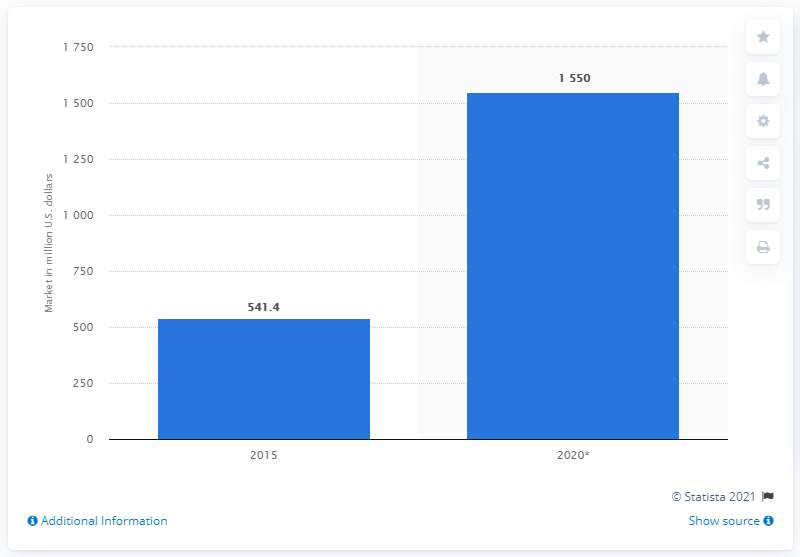Identify some key points in this picture. The e-mail encryption market began to grow in 2015. The estimated value of the global e-mail encryption market in 2020 was approximately $1550 in dollars. 